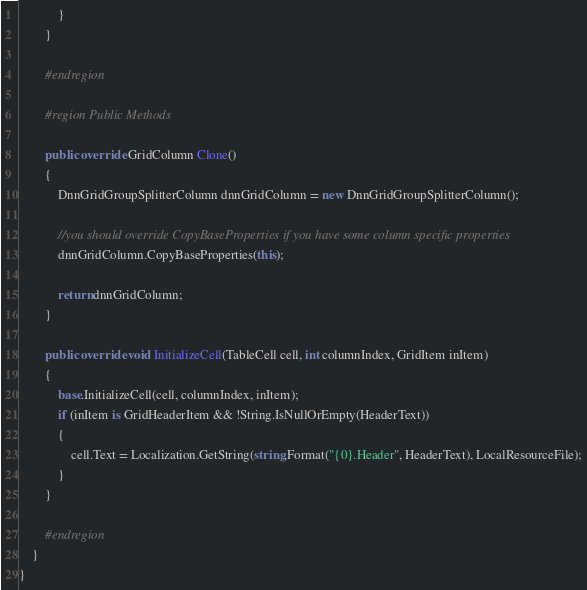<code> <loc_0><loc_0><loc_500><loc_500><_C#_>            }
        }

        #endregion

        #region Public Methods

        public override GridColumn Clone()
        {
            DnnGridGroupSplitterColumn dnnGridColumn = new DnnGridGroupSplitterColumn();

            //you should override CopyBaseProperties if you have some column specific properties
            dnnGridColumn.CopyBaseProperties(this);

            return dnnGridColumn;
        }

        public override void InitializeCell(TableCell cell, int columnIndex, GridItem inItem)
        {
            base.InitializeCell(cell, columnIndex, inItem);
            if (inItem is GridHeaderItem && !String.IsNullOrEmpty(HeaderText))
            {
                cell.Text = Localization.GetString(string.Format("{0}.Header", HeaderText), LocalResourceFile);
            }
        }

        #endregion
    }
}</code> 